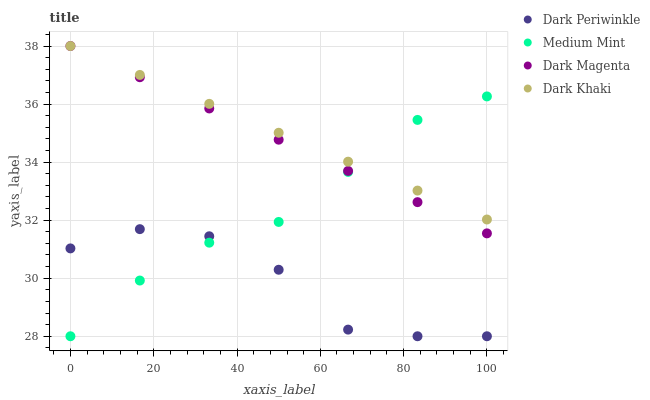Does Dark Periwinkle have the minimum area under the curve?
Answer yes or no. Yes. Does Dark Khaki have the maximum area under the curve?
Answer yes or no. Yes. Does Dark Khaki have the minimum area under the curve?
Answer yes or no. No. Does Dark Periwinkle have the maximum area under the curve?
Answer yes or no. No. Is Dark Khaki the smoothest?
Answer yes or no. Yes. Is Dark Periwinkle the roughest?
Answer yes or no. Yes. Is Dark Periwinkle the smoothest?
Answer yes or no. No. Is Dark Khaki the roughest?
Answer yes or no. No. Does Medium Mint have the lowest value?
Answer yes or no. Yes. Does Dark Khaki have the lowest value?
Answer yes or no. No. Does Dark Magenta have the highest value?
Answer yes or no. Yes. Does Dark Periwinkle have the highest value?
Answer yes or no. No. Is Dark Periwinkle less than Dark Magenta?
Answer yes or no. Yes. Is Dark Magenta greater than Dark Periwinkle?
Answer yes or no. Yes. Does Dark Khaki intersect Dark Magenta?
Answer yes or no. Yes. Is Dark Khaki less than Dark Magenta?
Answer yes or no. No. Is Dark Khaki greater than Dark Magenta?
Answer yes or no. No. Does Dark Periwinkle intersect Dark Magenta?
Answer yes or no. No. 